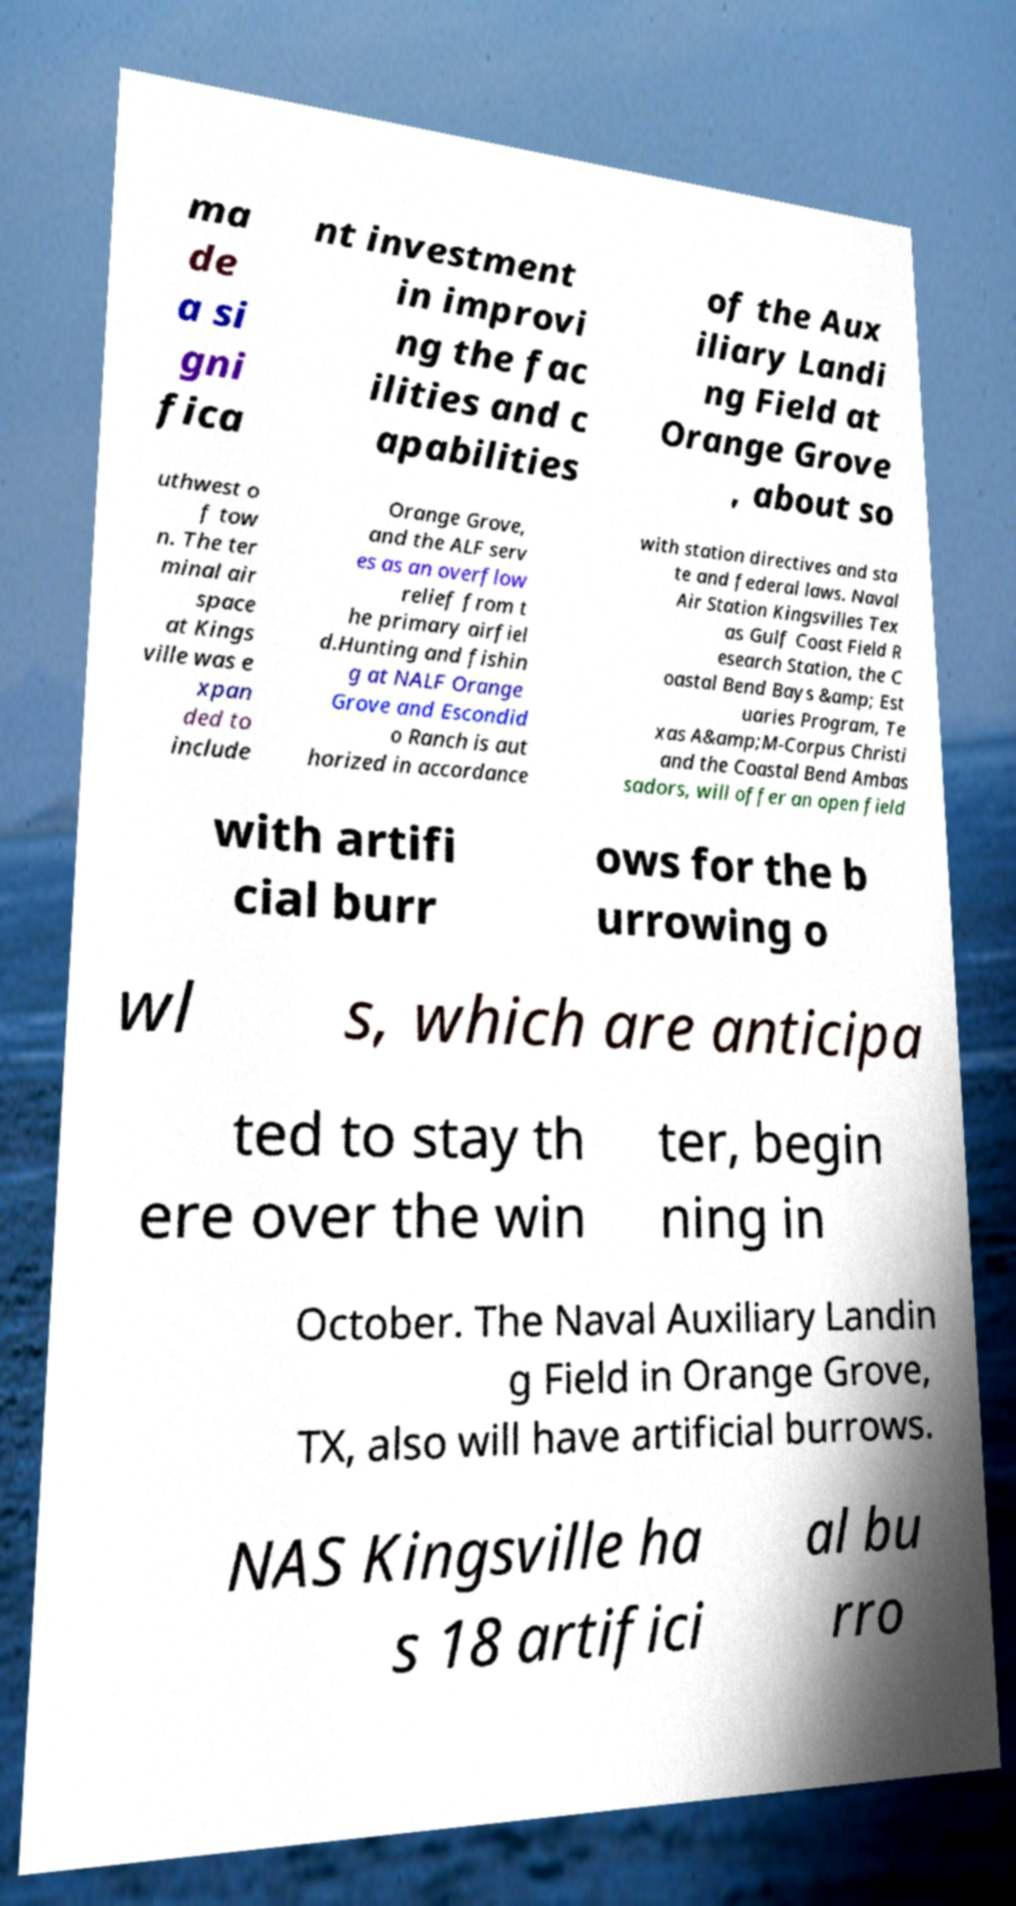There's text embedded in this image that I need extracted. Can you transcribe it verbatim? ma de a si gni fica nt investment in improvi ng the fac ilities and c apabilities of the Aux iliary Landi ng Field at Orange Grove , about so uthwest o f tow n. The ter minal air space at Kings ville was e xpan ded to include Orange Grove, and the ALF serv es as an overflow relief from t he primary airfiel d.Hunting and fishin g at NALF Orange Grove and Escondid o Ranch is aut horized in accordance with station directives and sta te and federal laws. Naval Air Station Kingsvilles Tex as Gulf Coast Field R esearch Station, the C oastal Bend Bays &amp; Est uaries Program, Te xas A&amp;M-Corpus Christi and the Coastal Bend Ambas sadors, will offer an open field with artifi cial burr ows for the b urrowing o wl s, which are anticipa ted to stay th ere over the win ter, begin ning in October. The Naval Auxiliary Landin g Field in Orange Grove, TX, also will have artificial burrows. NAS Kingsville ha s 18 artifici al bu rro 